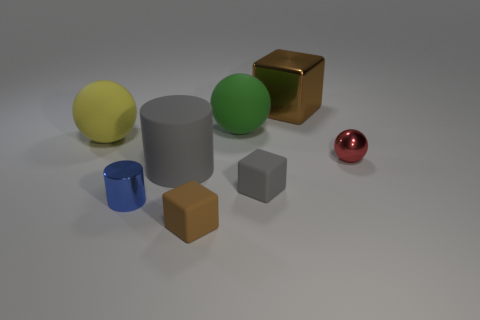Add 2 big cylinders. How many objects exist? 10 Subtract all cylinders. How many objects are left? 6 Subtract all small rubber objects. Subtract all tiny yellow rubber objects. How many objects are left? 6 Add 6 tiny blue things. How many tiny blue things are left? 7 Add 5 big red blocks. How many big red blocks exist? 5 Subtract 1 gray cubes. How many objects are left? 7 